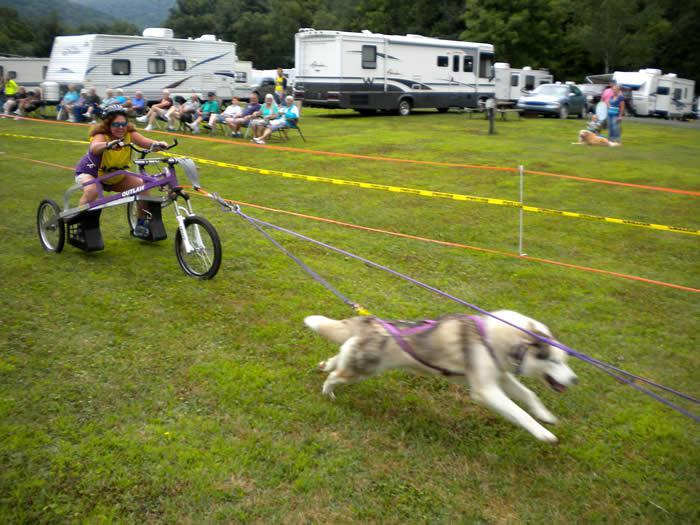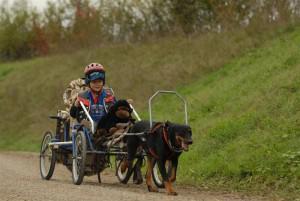The first image is the image on the left, the second image is the image on the right. Evaluate the accuracy of this statement regarding the images: "An image shows a person in a helmet riding a four-wheeled cart pulled by one dog diagonally to the right.". Is it true? Answer yes or no. Yes. The first image is the image on the left, the second image is the image on the right. Evaluate the accuracy of this statement regarding the images: "There are two dogs.". Is it true? Answer yes or no. Yes. 